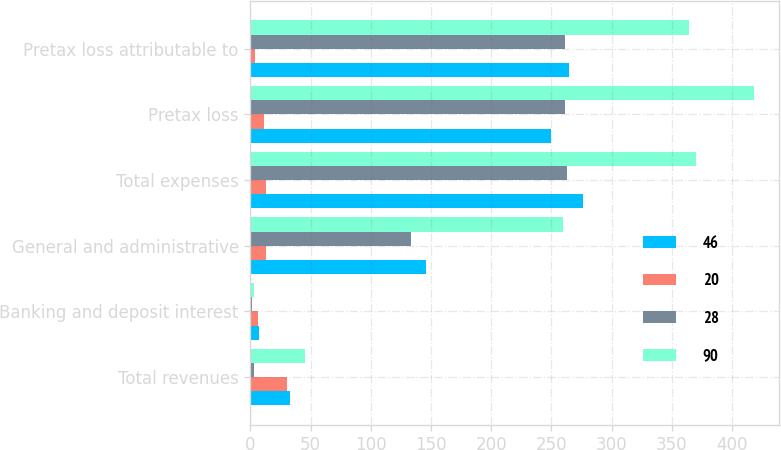Convert chart. <chart><loc_0><loc_0><loc_500><loc_500><stacked_bar_chart><ecel><fcel>Total revenues<fcel>Banking and deposit interest<fcel>General and administrative<fcel>Total expenses<fcel>Pretax loss<fcel>Pretax loss attributable to<nl><fcel>46<fcel>33<fcel>7<fcel>146<fcel>276<fcel>250<fcel>265<nl><fcel>20<fcel>30<fcel>6<fcel>13<fcel>13<fcel>11<fcel>4<nl><fcel>28<fcel>3<fcel>1<fcel>133<fcel>263<fcel>261<fcel>261<nl><fcel>90<fcel>45<fcel>3<fcel>260<fcel>370<fcel>418<fcel>364<nl></chart> 